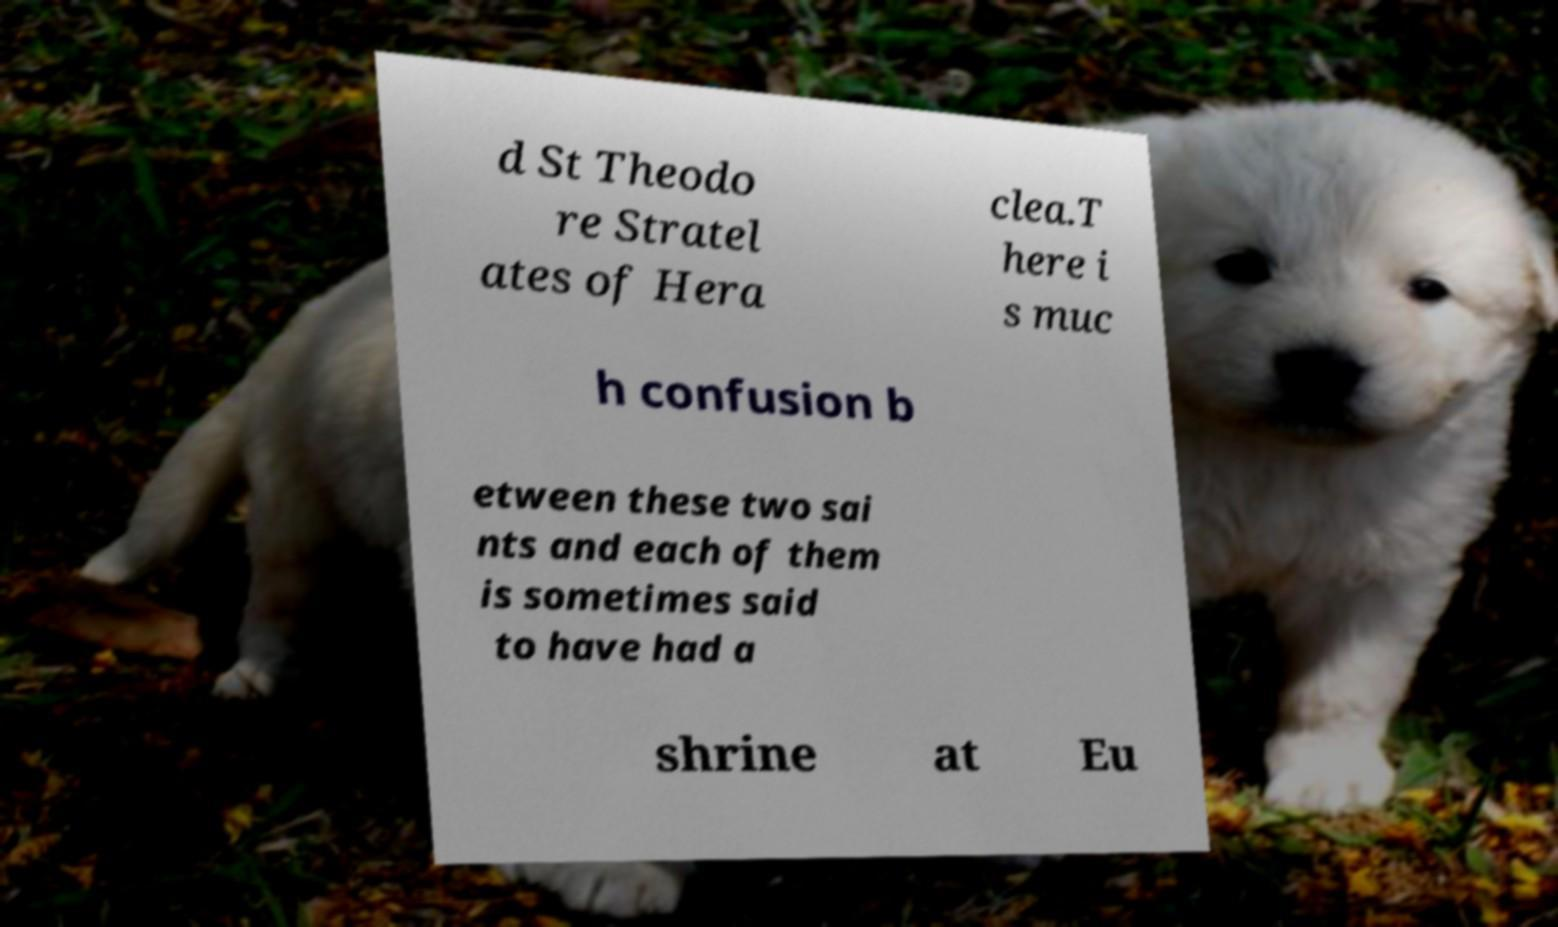Could you assist in decoding the text presented in this image and type it out clearly? d St Theodo re Stratel ates of Hera clea.T here i s muc h confusion b etween these two sai nts and each of them is sometimes said to have had a shrine at Eu 